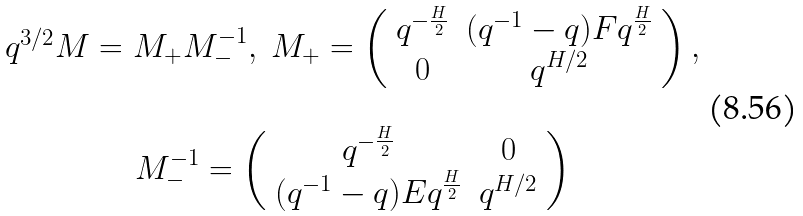<formula> <loc_0><loc_0><loc_500><loc_500>\begin{array} { c c } q ^ { 3 / 2 } M = M _ { + } M _ { - } ^ { - 1 } , \ M _ { + } = \left ( \begin{array} { c c } q ^ { - \frac { H } { 2 } } & ( q ^ { - 1 } - q ) F q ^ { \frac { H } { 2 } } \\ 0 & q ^ { H / 2 } \end{array} \right ) , \\ \\ M ^ { - 1 } _ { - } = \left ( \begin{array} { c c } q ^ { - \frac { H } { 2 } } & 0 \\ ( q ^ { - 1 } - q ) E q ^ { \frac { H } { 2 } } & q ^ { H / 2 } \end{array} \right ) \end{array}</formula> 